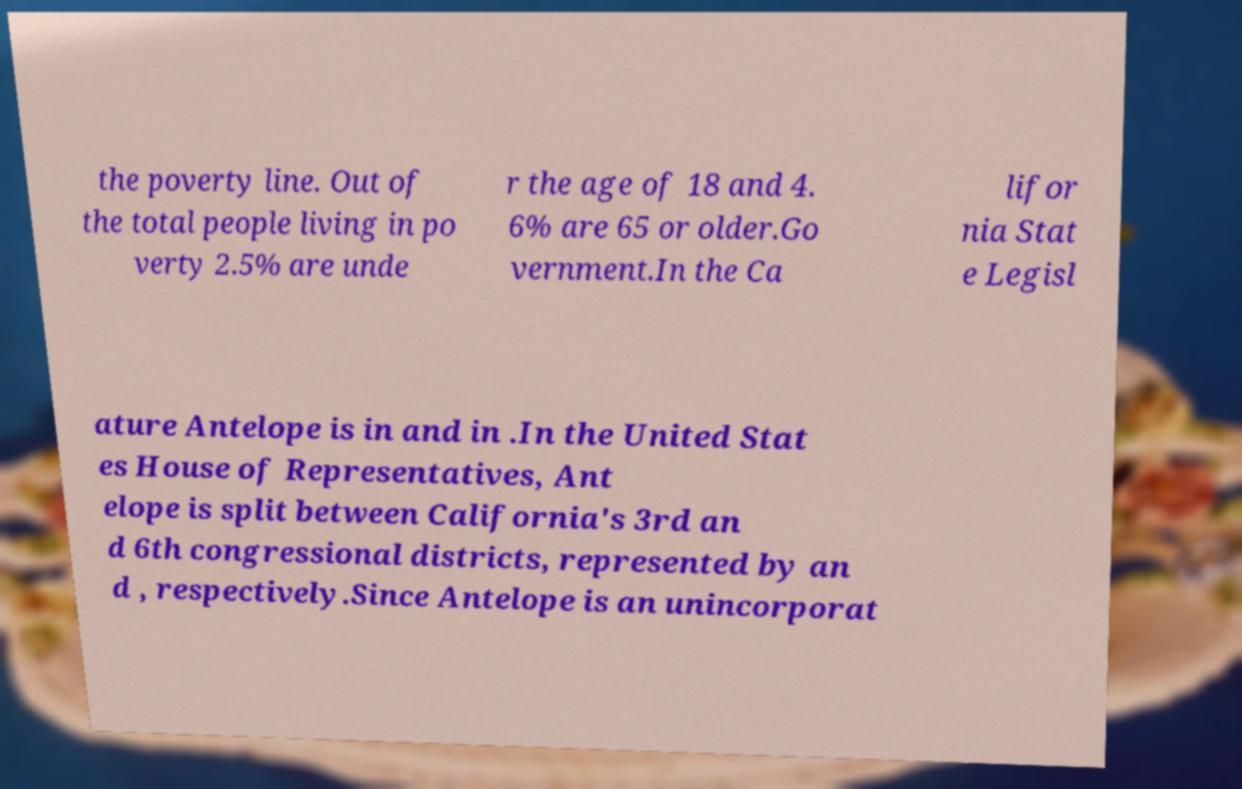Could you extract and type out the text from this image? the poverty line. Out of the total people living in po verty 2.5% are unde r the age of 18 and 4. 6% are 65 or older.Go vernment.In the Ca lifor nia Stat e Legisl ature Antelope is in and in .In the United Stat es House of Representatives, Ant elope is split between California's 3rd an d 6th congressional districts, represented by an d , respectively.Since Antelope is an unincorporat 